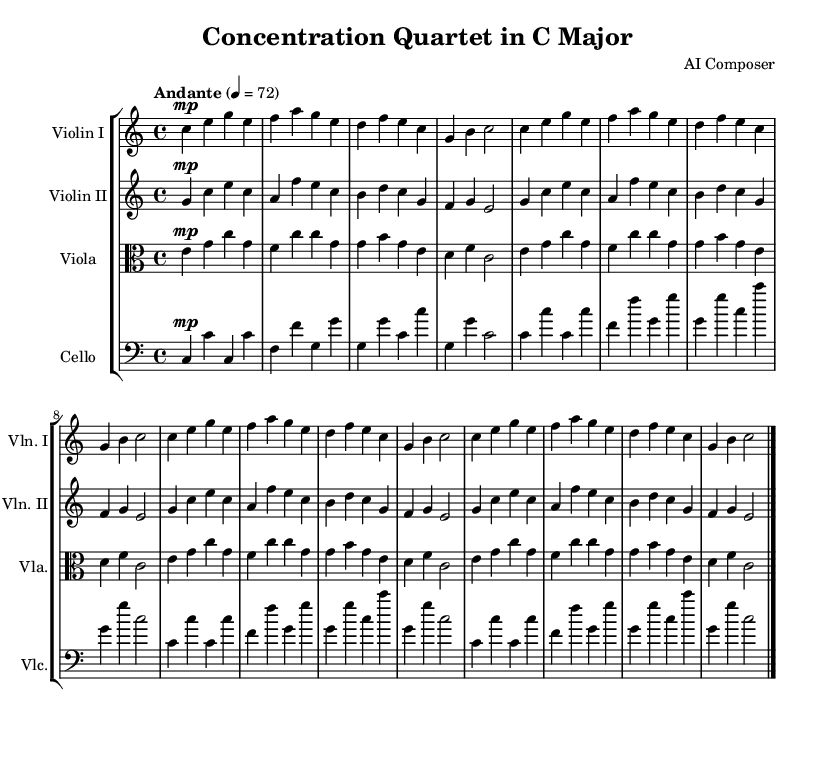What is the key signature of this music? The key signature is indicated at the beginning of the staff, and since it shows no sharps or flats, it represents C major.
Answer: C major What is the time signature of this piece? The time signature is located at the beginning of the score, and it shows a 4 over 4, indicating four beats in each measure.
Answer: 4/4 What is the tempo marking of this quartet? The tempo marking "Andante" is specified in the score, indicating a moderate pace. The numerical indication "4 = 72" confirms it refers to a quarter note meant to be played at 72 beats per minute.
Answer: Andante How many measures are there in each repeat section? Each repeat section in the score consists of 4 measures, as noticed in the repeated patterns clearly delineated by the slashes in the music lines.
Answer: 4 What instrument is playing the lowest part in this quartet? Reviewing the instrumentation of the quartet, the cello, which has the lowest clef (bass), plays the lowest part.
Answer: Cello Which instrument has the highest pitch range in this arrangement? Analyzing the instrument parts, the first violin generally plays in the highest pitch range compared to the other instruments in the quartet.
Answer: Violin I How many times is the main theme repeated in this score? By examining the repeated music sections indicated in the score, the main theme is repeated three times after the first statement of the theme, resulting in a total of four occurrences.
Answer: 4 